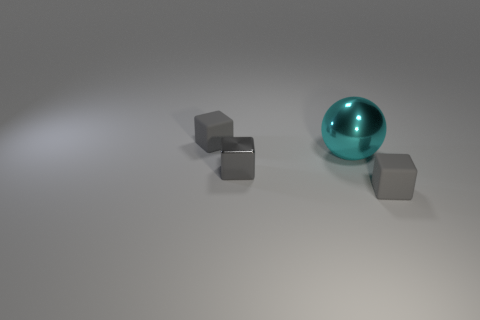Subtract all small gray matte blocks. How many blocks are left? 1 Add 2 large balls. How many objects exist? 6 Subtract all spheres. How many objects are left? 3 Add 1 gray blocks. How many gray blocks exist? 4 Subtract 0 purple spheres. How many objects are left? 4 Subtract 1 blocks. How many blocks are left? 2 Subtract all yellow cubes. Subtract all yellow cylinders. How many cubes are left? 3 Subtract all tiny shiny blocks. Subtract all purple shiny objects. How many objects are left? 3 Add 1 cubes. How many cubes are left? 4 